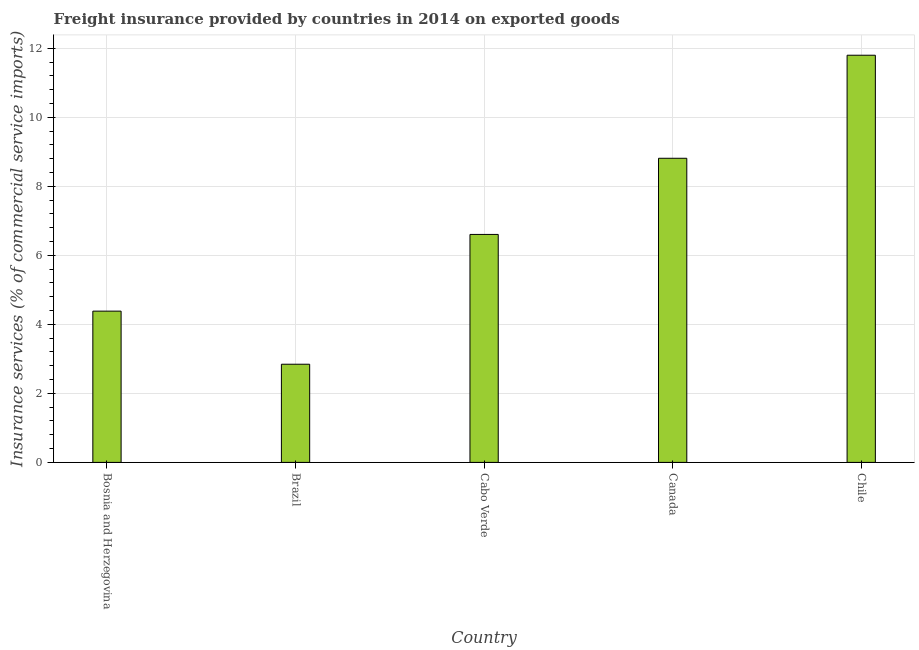What is the title of the graph?
Your response must be concise. Freight insurance provided by countries in 2014 on exported goods . What is the label or title of the Y-axis?
Keep it short and to the point. Insurance services (% of commercial service imports). What is the freight insurance in Cabo Verde?
Offer a very short reply. 6.61. Across all countries, what is the maximum freight insurance?
Make the answer very short. 11.8. Across all countries, what is the minimum freight insurance?
Your response must be concise. 2.85. In which country was the freight insurance minimum?
Make the answer very short. Brazil. What is the sum of the freight insurance?
Make the answer very short. 34.46. What is the difference between the freight insurance in Bosnia and Herzegovina and Brazil?
Your response must be concise. 1.54. What is the average freight insurance per country?
Give a very brief answer. 6.89. What is the median freight insurance?
Give a very brief answer. 6.61. What is the ratio of the freight insurance in Brazil to that in Chile?
Your answer should be compact. 0.24. Is the difference between the freight insurance in Bosnia and Herzegovina and Chile greater than the difference between any two countries?
Your response must be concise. No. What is the difference between the highest and the second highest freight insurance?
Provide a succinct answer. 2.99. What is the difference between the highest and the lowest freight insurance?
Offer a terse response. 8.96. In how many countries, is the freight insurance greater than the average freight insurance taken over all countries?
Your answer should be compact. 2. How many bars are there?
Offer a very short reply. 5. How many countries are there in the graph?
Make the answer very short. 5. What is the difference between two consecutive major ticks on the Y-axis?
Your answer should be compact. 2. What is the Insurance services (% of commercial service imports) in Bosnia and Herzegovina?
Your answer should be compact. 4.38. What is the Insurance services (% of commercial service imports) of Brazil?
Offer a terse response. 2.85. What is the Insurance services (% of commercial service imports) in Cabo Verde?
Your answer should be compact. 6.61. What is the Insurance services (% of commercial service imports) of Canada?
Keep it short and to the point. 8.82. What is the Insurance services (% of commercial service imports) of Chile?
Offer a very short reply. 11.8. What is the difference between the Insurance services (% of commercial service imports) in Bosnia and Herzegovina and Brazil?
Offer a very short reply. 1.54. What is the difference between the Insurance services (% of commercial service imports) in Bosnia and Herzegovina and Cabo Verde?
Ensure brevity in your answer.  -2.22. What is the difference between the Insurance services (% of commercial service imports) in Bosnia and Herzegovina and Canada?
Give a very brief answer. -4.43. What is the difference between the Insurance services (% of commercial service imports) in Bosnia and Herzegovina and Chile?
Your response must be concise. -7.42. What is the difference between the Insurance services (% of commercial service imports) in Brazil and Cabo Verde?
Offer a terse response. -3.76. What is the difference between the Insurance services (% of commercial service imports) in Brazil and Canada?
Give a very brief answer. -5.97. What is the difference between the Insurance services (% of commercial service imports) in Brazil and Chile?
Offer a terse response. -8.96. What is the difference between the Insurance services (% of commercial service imports) in Cabo Verde and Canada?
Your response must be concise. -2.21. What is the difference between the Insurance services (% of commercial service imports) in Cabo Verde and Chile?
Your answer should be very brief. -5.19. What is the difference between the Insurance services (% of commercial service imports) in Canada and Chile?
Ensure brevity in your answer.  -2.99. What is the ratio of the Insurance services (% of commercial service imports) in Bosnia and Herzegovina to that in Brazil?
Give a very brief answer. 1.54. What is the ratio of the Insurance services (% of commercial service imports) in Bosnia and Herzegovina to that in Cabo Verde?
Make the answer very short. 0.66. What is the ratio of the Insurance services (% of commercial service imports) in Bosnia and Herzegovina to that in Canada?
Ensure brevity in your answer.  0.5. What is the ratio of the Insurance services (% of commercial service imports) in Bosnia and Herzegovina to that in Chile?
Offer a very short reply. 0.37. What is the ratio of the Insurance services (% of commercial service imports) in Brazil to that in Cabo Verde?
Provide a succinct answer. 0.43. What is the ratio of the Insurance services (% of commercial service imports) in Brazil to that in Canada?
Your answer should be compact. 0.32. What is the ratio of the Insurance services (% of commercial service imports) in Brazil to that in Chile?
Give a very brief answer. 0.24. What is the ratio of the Insurance services (% of commercial service imports) in Cabo Verde to that in Canada?
Your response must be concise. 0.75. What is the ratio of the Insurance services (% of commercial service imports) in Cabo Verde to that in Chile?
Your answer should be compact. 0.56. What is the ratio of the Insurance services (% of commercial service imports) in Canada to that in Chile?
Keep it short and to the point. 0.75. 